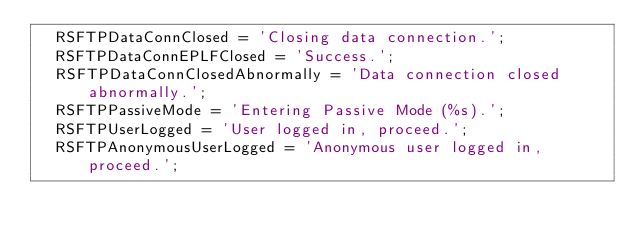Convert code to text. <code><loc_0><loc_0><loc_500><loc_500><_Pascal_>  RSFTPDataConnClosed = 'Closing data connection.';
  RSFTPDataConnEPLFClosed = 'Success.';
  RSFTPDataConnClosedAbnormally = 'Data connection closed abnormally.';
  RSFTPPassiveMode = 'Entering Passive Mode (%s).';
  RSFTPUserLogged = 'User logged in, proceed.';
  RSFTPAnonymousUserLogged = 'Anonymous user logged in, proceed.';</code> 